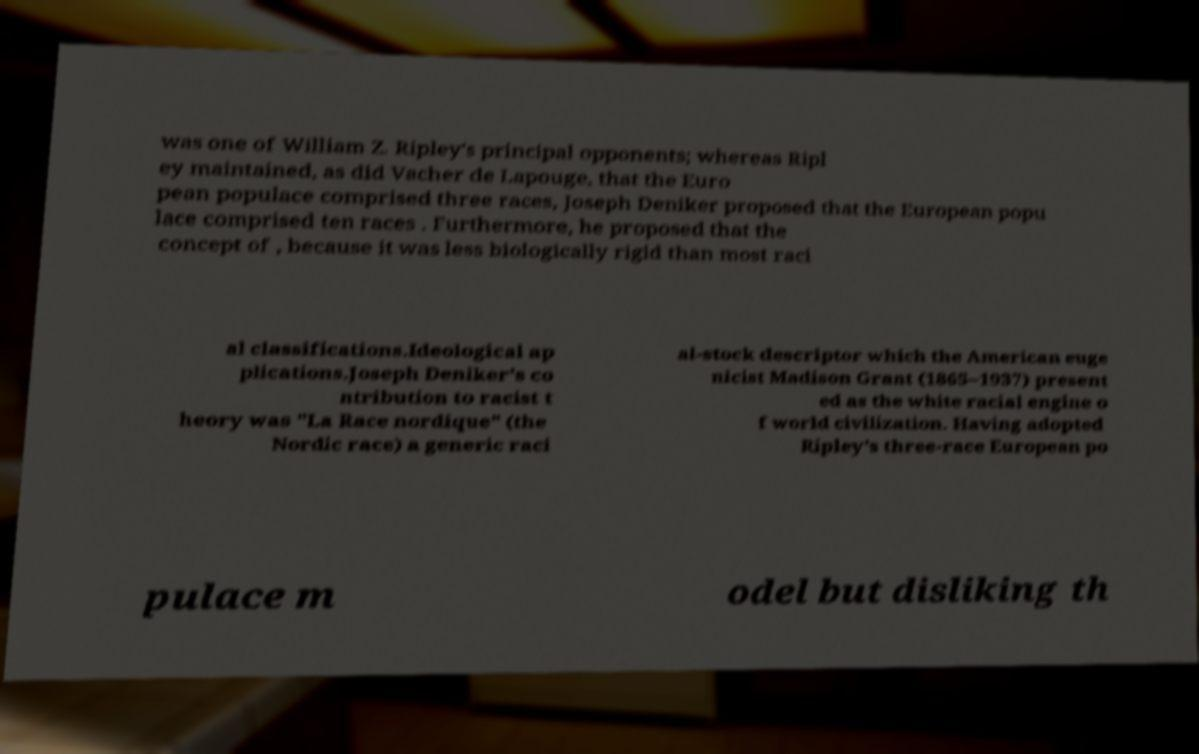Could you assist in decoding the text presented in this image and type it out clearly? was one of William Z. Ripley's principal opponents; whereas Ripl ey maintained, as did Vacher de Lapouge, that the Euro pean populace comprised three races, Joseph Deniker proposed that the European popu lace comprised ten races . Furthermore, he proposed that the concept of , because it was less biologically rigid than most raci al classifications.Ideological ap plications.Joseph Deniker's co ntribution to racist t heory was "La Race nordique" (the Nordic race) a generic raci al-stock descriptor which the American euge nicist Madison Grant (1865–1937) present ed as the white racial engine o f world civilization. Having adopted Ripley's three-race European po pulace m odel but disliking th 